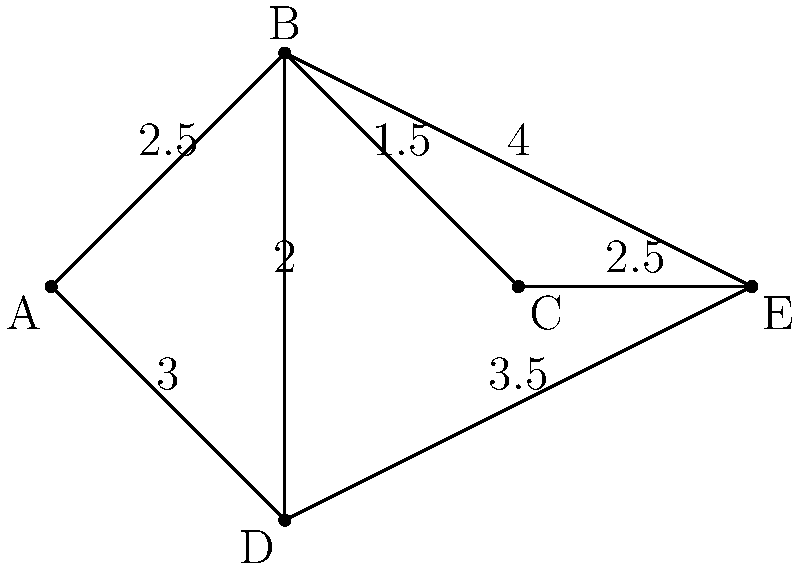In the transportation network shown above, where nodes represent cities and edges represent roads with their corresponding distances (in kilometers), determine the total length of the minimum spanning tree. How might this information be useful for someone planning an efficient route through all cities? To find the minimum spanning tree (MST) of this weighted graph, we'll use Kruskal's algorithm:

1. Sort all edges by weight in ascending order:
   B-C (1.5), B-D (2.0), A-B (2.5), C-E (2.5), A-D (3.0), D-E (3.5), B-E (4.0)

2. Start with an empty MST and add edges that don't create cycles:
   - Add B-C (1.5)
   - Add B-D (2.0)
   - Add A-B (2.5)
   - Add C-E (2.5)

3. The MST is complete as it now includes all 5 vertices.

4. Calculate the total length of the MST:
   $1.5 + 2.0 + 2.5 + 2.5 = 8.5$ km

This information can be useful for planning an efficient route because:
1. It provides the minimum total distance to connect all cities.
2. It helps identify the most important roads for maintaining connectivity.
3. It can serve as a starting point for route optimization, allowing for detours if needed.

For a shy and introverted student, understanding this concept might help in efficiently planning group projects or social interactions with minimum effort while still connecting with all necessary people.
Answer: 8.5 km 